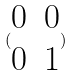<formula> <loc_0><loc_0><loc_500><loc_500>( \begin{matrix} 0 & 0 \\ 0 & 1 \end{matrix} )</formula> 